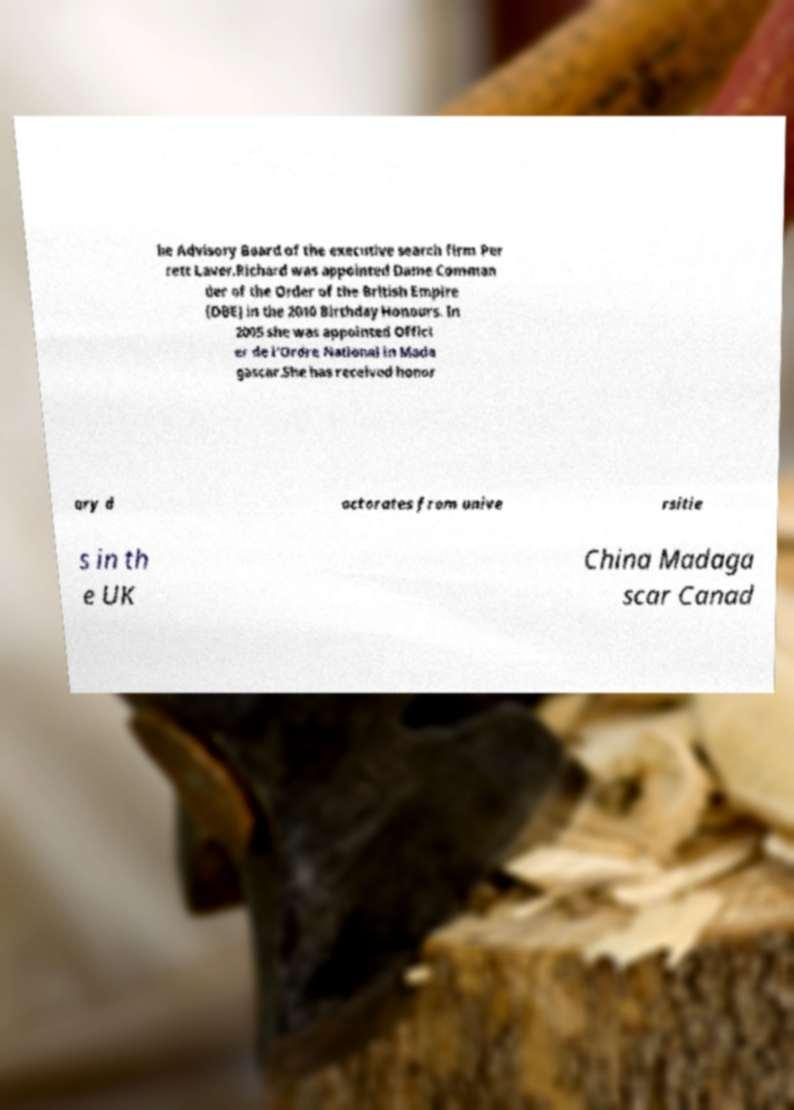There's text embedded in this image that I need extracted. Can you transcribe it verbatim? he Advisory Board of the executive search firm Per rett Laver.Richard was appointed Dame Comman der of the Order of the British Empire (DBE) in the 2010 Birthday Honours. In 2005 she was appointed Offici er de l'Ordre National in Mada gascar.She has received honor ary d octorates from unive rsitie s in th e UK China Madaga scar Canad 